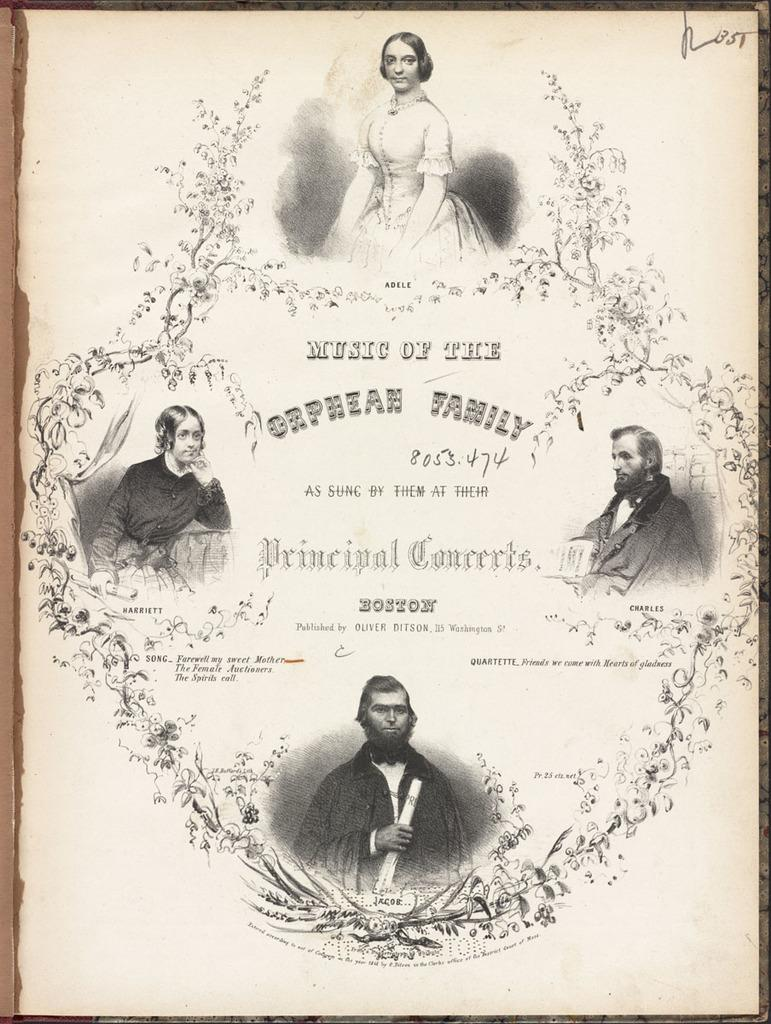What is depicted on the paper in the image? There are four people on the paper in the image. What are the people wearing? The people are wearing dresses. Is there any text on the paper? Yes, there is text written between the people on the paper. What type of blade can be seen cutting the pie in the image? There is no pie or blade present in the image; it features a paper with four people and text. 